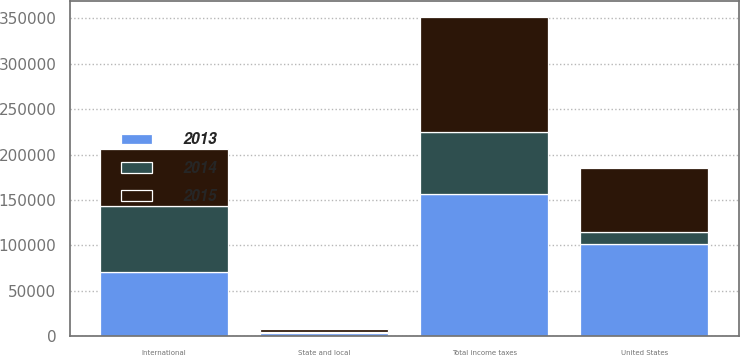<chart> <loc_0><loc_0><loc_500><loc_500><stacked_bar_chart><ecel><fcel>United States<fcel>State and local<fcel>International<fcel>Total income taxes<nl><fcel>2013<fcel>101591<fcel>3352<fcel>71054<fcel>157043<nl><fcel>2015<fcel>70390<fcel>3134<fcel>62909<fcel>126678<nl><fcel>2014<fcel>12760<fcel>1677<fcel>72640<fcel>67894<nl></chart> 